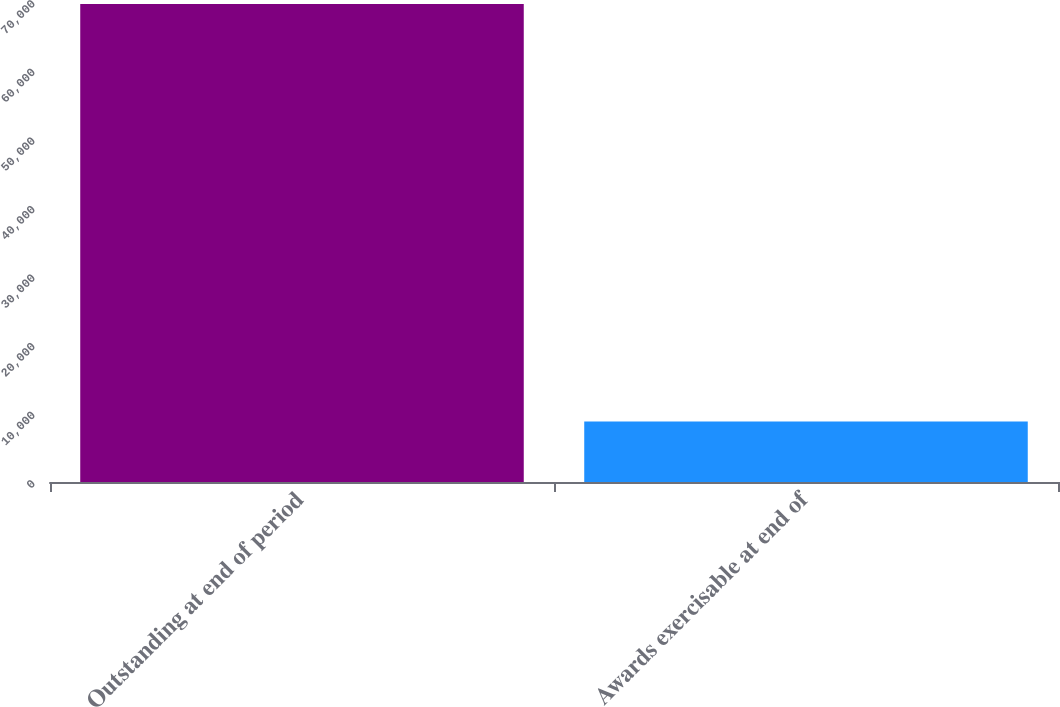Convert chart. <chart><loc_0><loc_0><loc_500><loc_500><bar_chart><fcel>Outstanding at end of period<fcel>Awards exercisable at end of<nl><fcel>69696<fcel>8810<nl></chart> 